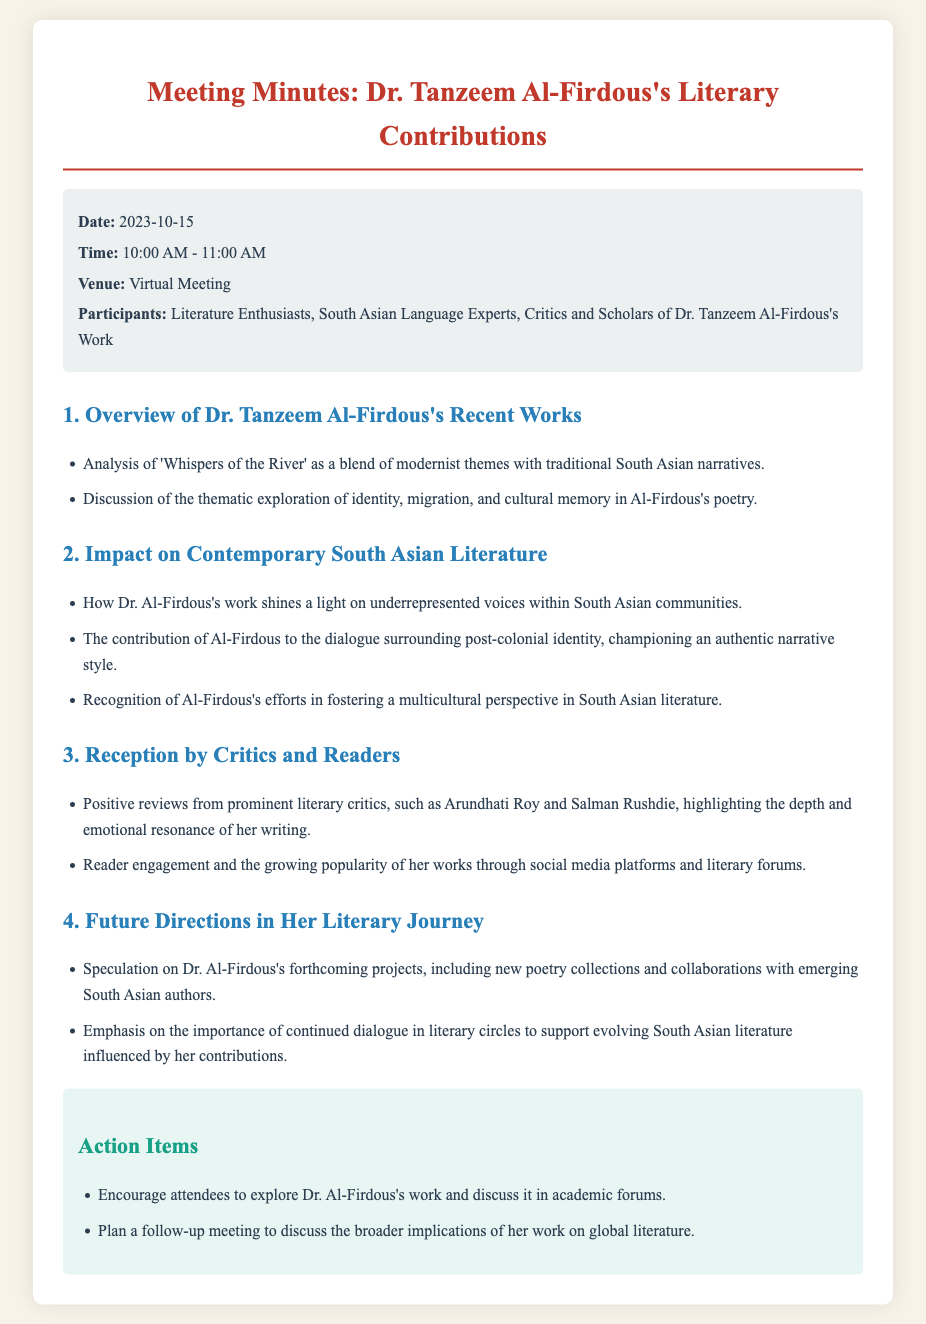what is the date of the meeting? The date is mentioned in the meta-info section of the document.
Answer: 2023-10-15 who are the participants of the meeting? The participants are listed in the meta-info section of the document.
Answer: Literature Enthusiasts, South Asian Language Experts, Critics and Scholars what is the title of Dr. Tanzeem Al-Firdous's work discussed in the overview? The specific title of her work is given in the first bullet point under the overview section.
Answer: Whispers of the River what themes are explored in Al-Firdous's poetry? The themes are summarized in a bullet point under the overview section of the document.
Answer: identity, migration, and cultural memory which literary critics provided positive reviews of Dr. Al-Firdous's work? The names of the critics are mentioned in the reception section of the document.
Answer: Arundhati Roy and Salman Rushdie what is emphasized for the future directions in Al-Firdous's literary journey? The future directions are highlighted in a bullet point indicating the ongoing importance of certain discussions in literary circles.
Answer: continued dialogue in literary circles what is one action item from the meeting? The action items are listed in the action items section of the document.
Answer: Explore Dr. Al-Firdous's work and discuss it in academic forums how long did the meeting last? The duration is indicated in the meta-info section of the document.
Answer: 1 hour 